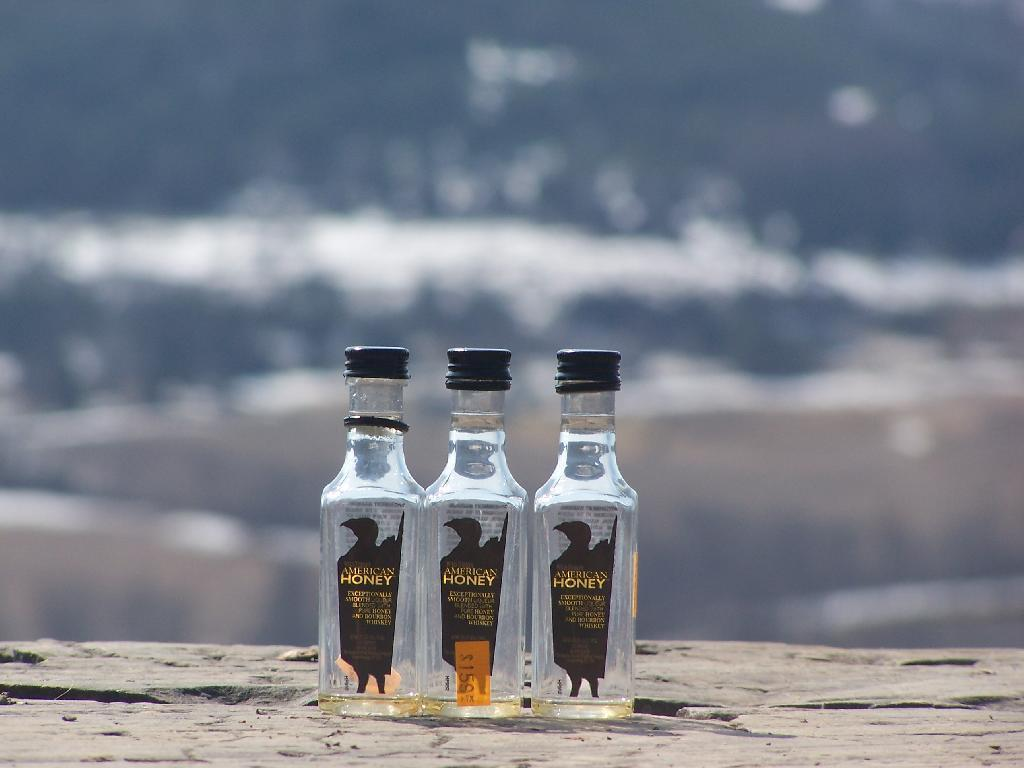<image>
Give a short and clear explanation of the subsequent image. Three bottles sitting on the beach with American Honey in gold lettering. 